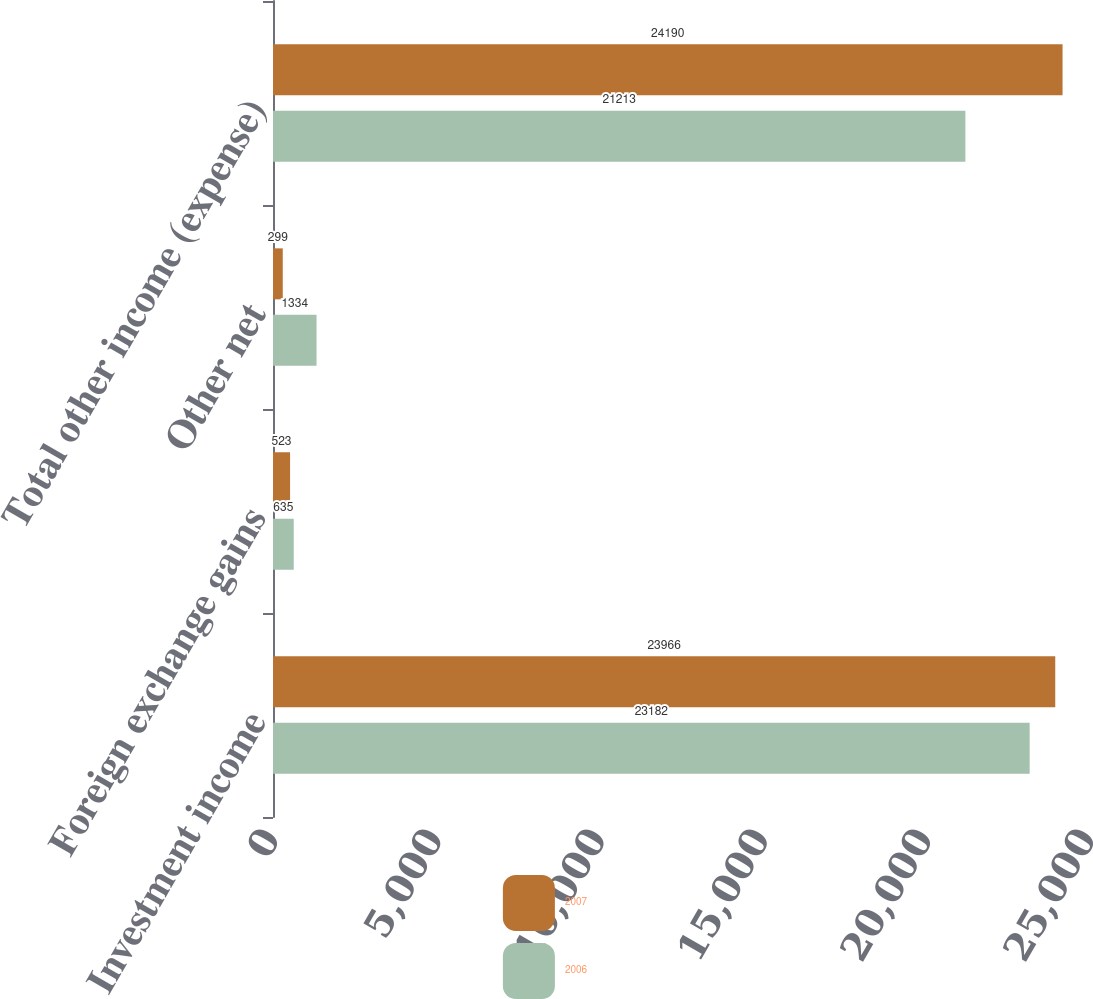Convert chart to OTSL. <chart><loc_0><loc_0><loc_500><loc_500><stacked_bar_chart><ecel><fcel>Investment income<fcel>Foreign exchange gains<fcel>Other net<fcel>Total other income (expense)<nl><fcel>2007<fcel>23966<fcel>523<fcel>299<fcel>24190<nl><fcel>2006<fcel>23182<fcel>635<fcel>1334<fcel>21213<nl></chart> 